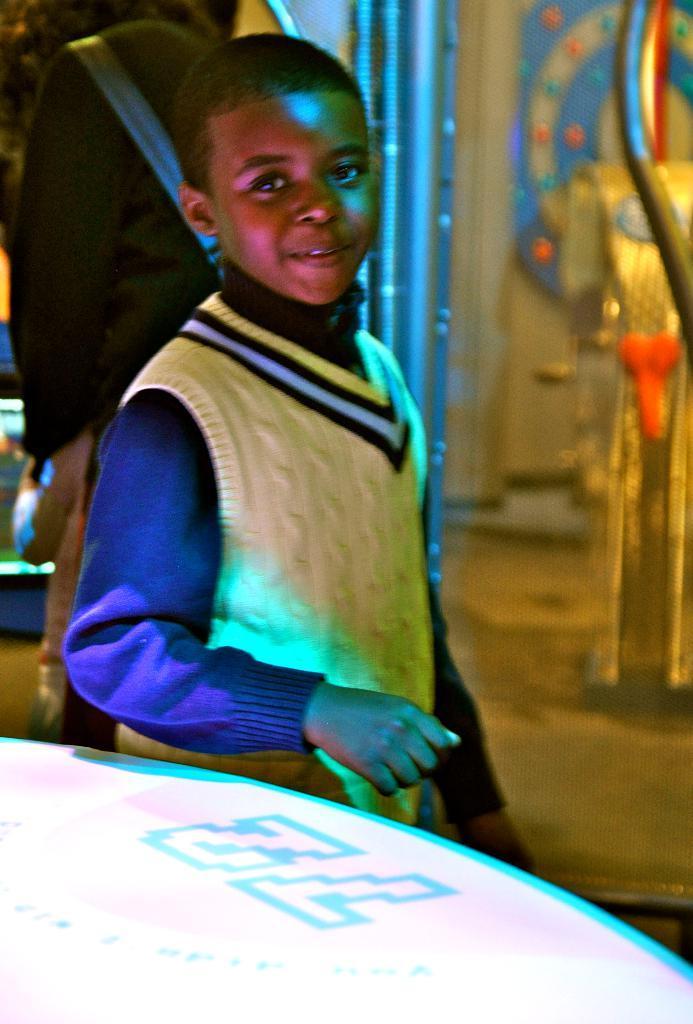Describe this image in one or two sentences. In this picture there is a boy who is wearing jacket and blue shirt. He is standing near to the table. In the back there is a woman who is wearing black dress and bag. On the left we can see the gaming home. 